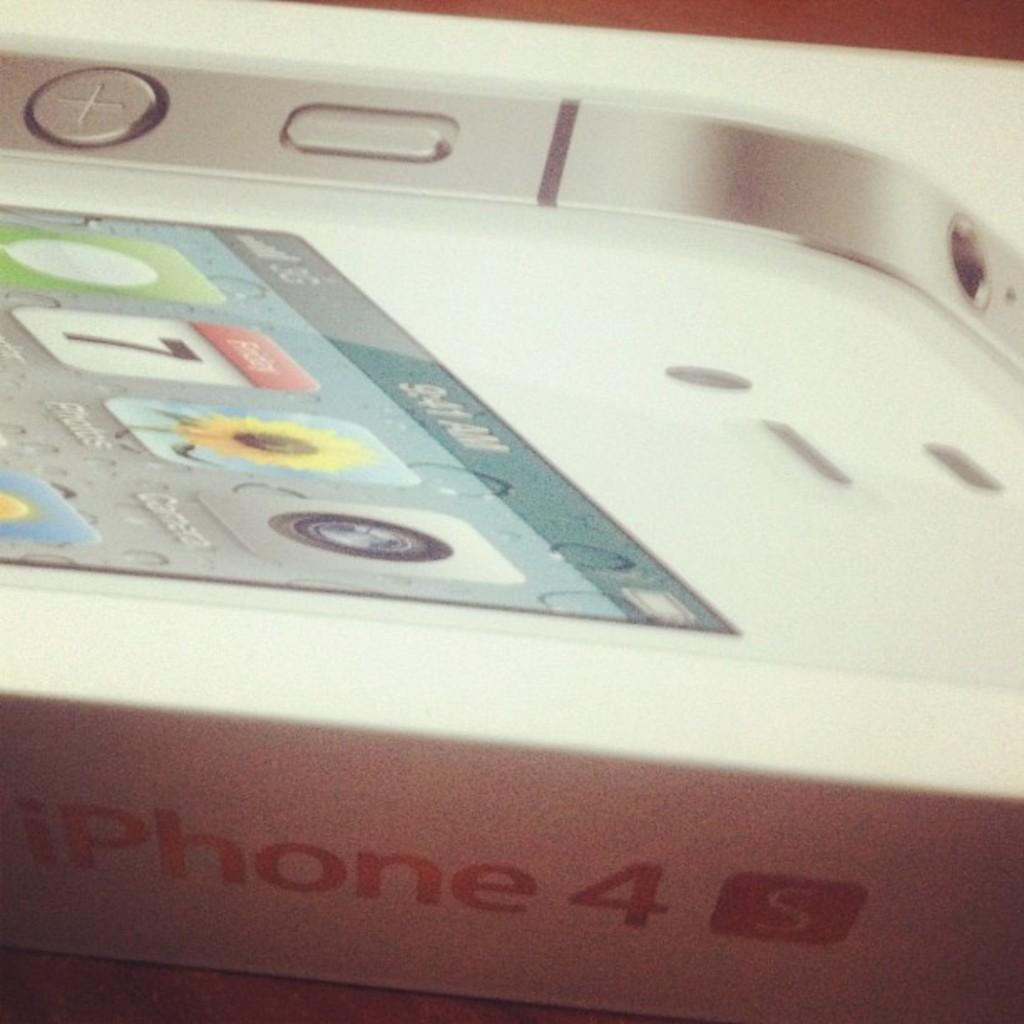<image>
Share a concise interpretation of the image provided. A box with the logo iPhone 4 written on the side which contains a cellphone. 